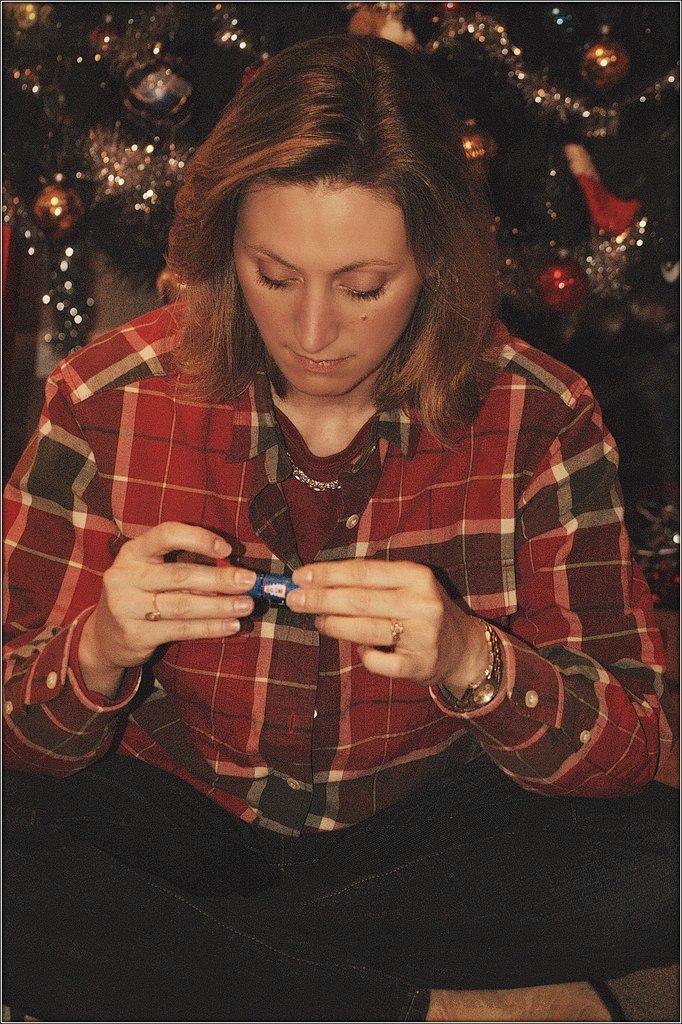Can you describe this image briefly? In this image we can see a woman holding an object. Behind the woman we can see the decorative items. 